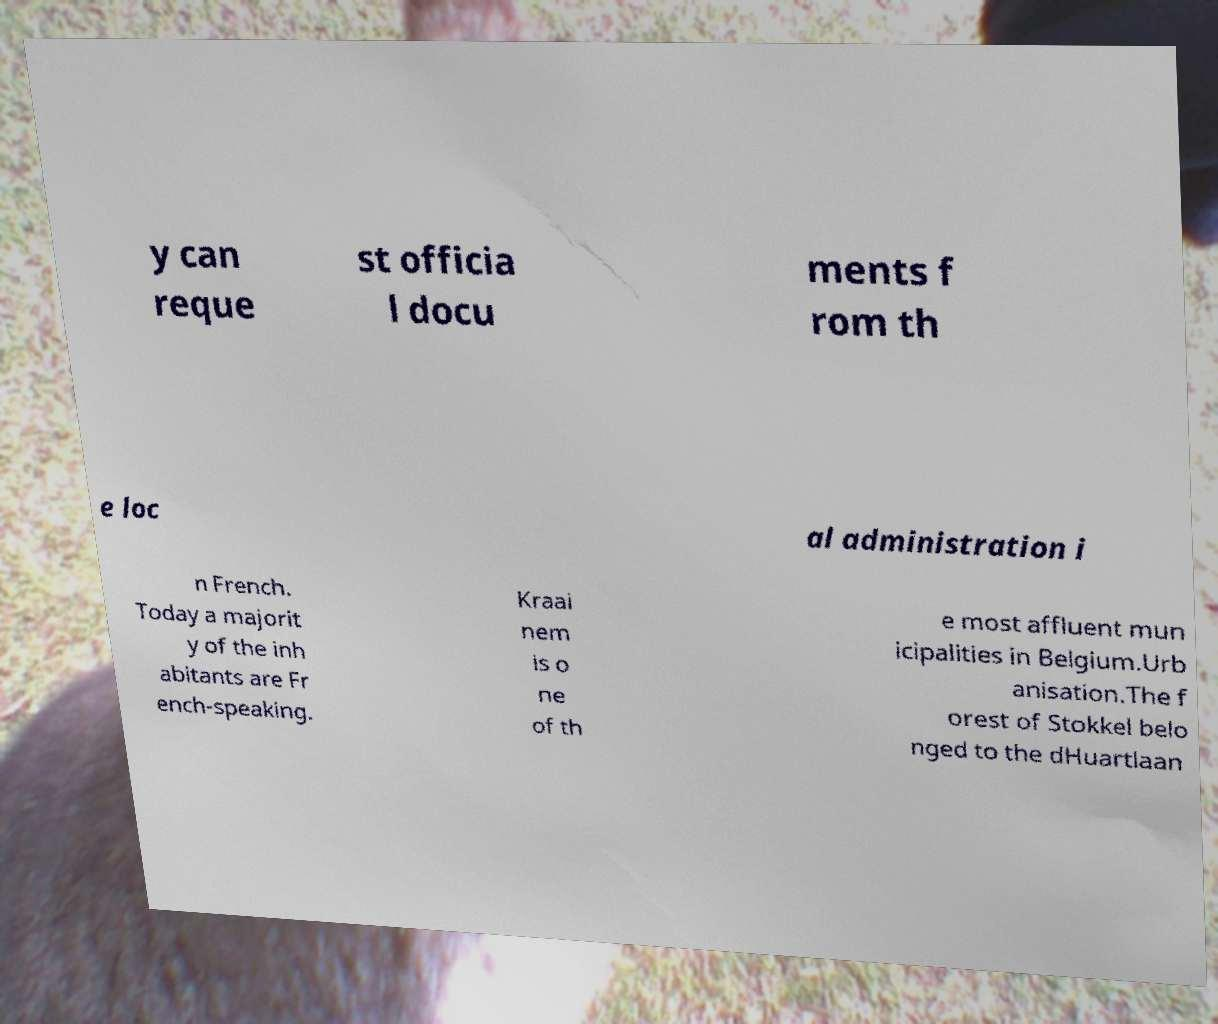Could you extract and type out the text from this image? y can reque st officia l docu ments f rom th e loc al administration i n French. Today a majorit y of the inh abitants are Fr ench-speaking. Kraai nem is o ne of th e most affluent mun icipalities in Belgium.Urb anisation.The f orest of Stokkel belo nged to the dHuartlaan 